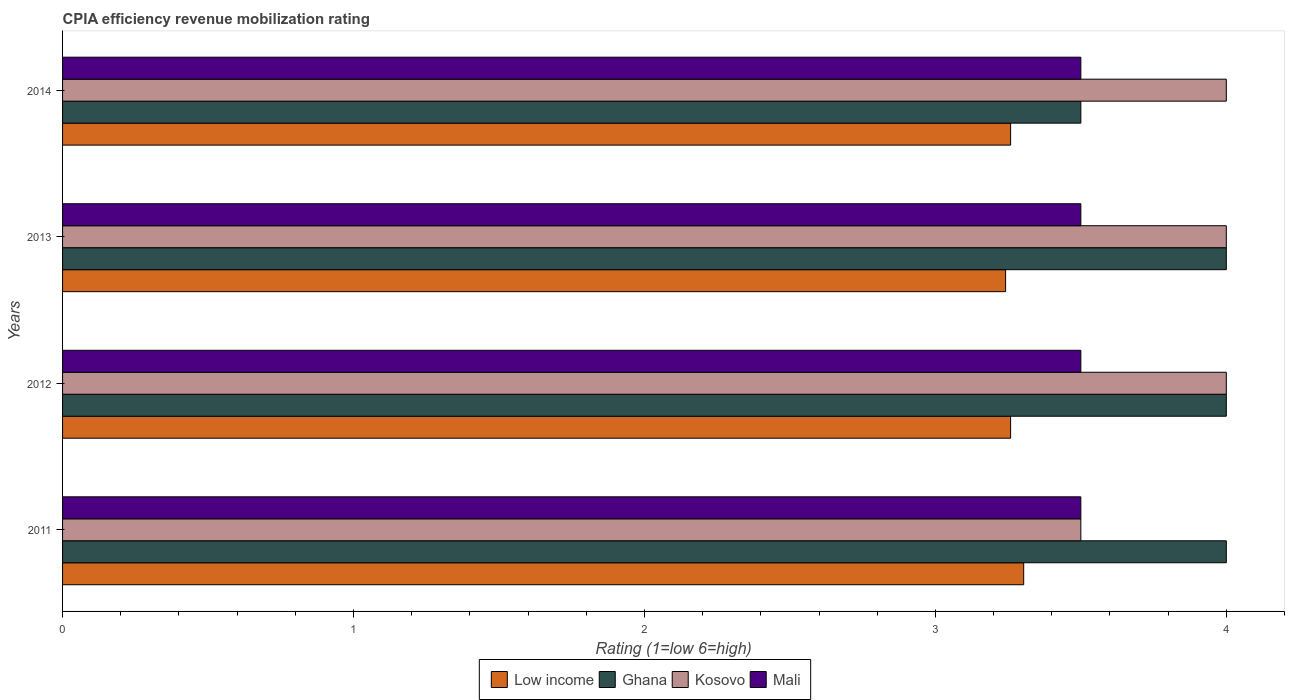How many different coloured bars are there?
Provide a short and direct response. 4. How many groups of bars are there?
Keep it short and to the point. 4. Are the number of bars on each tick of the Y-axis equal?
Provide a succinct answer. Yes. How many bars are there on the 1st tick from the top?
Give a very brief answer. 4. What is the label of the 4th group of bars from the top?
Ensure brevity in your answer.  2011. In how many cases, is the number of bars for a given year not equal to the number of legend labels?
Give a very brief answer. 0. In which year was the CPIA rating in Low income maximum?
Provide a short and direct response. 2011. In which year was the CPIA rating in Low income minimum?
Your answer should be compact. 2013. What is the total CPIA rating in Mali in the graph?
Offer a very short reply. 14. What is the difference between the CPIA rating in Mali in 2011 and that in 2012?
Your answer should be compact. 0. What is the average CPIA rating in Ghana per year?
Ensure brevity in your answer.  3.88. In the year 2014, what is the difference between the CPIA rating in Ghana and CPIA rating in Mali?
Offer a very short reply. 0. In how many years, is the CPIA rating in Mali greater than 1.2 ?
Provide a succinct answer. 4. What is the ratio of the CPIA rating in Low income in 2011 to that in 2012?
Offer a very short reply. 1.01. What is the difference between the highest and the lowest CPIA rating in Low income?
Provide a short and direct response. 0.06. In how many years, is the CPIA rating in Low income greater than the average CPIA rating in Low income taken over all years?
Your response must be concise. 1. Is the sum of the CPIA rating in Mali in 2011 and 2014 greater than the maximum CPIA rating in Low income across all years?
Keep it short and to the point. Yes. What does the 3rd bar from the top in 2012 represents?
Ensure brevity in your answer.  Ghana. What does the 2nd bar from the bottom in 2013 represents?
Give a very brief answer. Ghana. Is it the case that in every year, the sum of the CPIA rating in Low income and CPIA rating in Kosovo is greater than the CPIA rating in Ghana?
Ensure brevity in your answer.  Yes. Are all the bars in the graph horizontal?
Your response must be concise. Yes. How many years are there in the graph?
Provide a short and direct response. 4. What is the difference between two consecutive major ticks on the X-axis?
Provide a succinct answer. 1. Are the values on the major ticks of X-axis written in scientific E-notation?
Offer a very short reply. No. Does the graph contain any zero values?
Your response must be concise. No. Does the graph contain grids?
Keep it short and to the point. No. Where does the legend appear in the graph?
Make the answer very short. Bottom center. How many legend labels are there?
Keep it short and to the point. 4. How are the legend labels stacked?
Provide a succinct answer. Horizontal. What is the title of the graph?
Give a very brief answer. CPIA efficiency revenue mobilization rating. What is the label or title of the X-axis?
Provide a succinct answer. Rating (1=low 6=high). What is the Rating (1=low 6=high) in Low income in 2011?
Your answer should be compact. 3.3. What is the Rating (1=low 6=high) of Ghana in 2011?
Offer a very short reply. 4. What is the Rating (1=low 6=high) in Low income in 2012?
Offer a very short reply. 3.26. What is the Rating (1=low 6=high) of Ghana in 2012?
Offer a very short reply. 4. What is the Rating (1=low 6=high) of Kosovo in 2012?
Offer a very short reply. 4. What is the Rating (1=low 6=high) of Low income in 2013?
Offer a very short reply. 3.24. What is the Rating (1=low 6=high) of Kosovo in 2013?
Offer a very short reply. 4. What is the Rating (1=low 6=high) in Mali in 2013?
Keep it short and to the point. 3.5. What is the Rating (1=low 6=high) of Low income in 2014?
Provide a succinct answer. 3.26. What is the Rating (1=low 6=high) in Ghana in 2014?
Provide a short and direct response. 3.5. What is the Rating (1=low 6=high) of Mali in 2014?
Make the answer very short. 3.5. Across all years, what is the maximum Rating (1=low 6=high) in Low income?
Your answer should be very brief. 3.3. Across all years, what is the minimum Rating (1=low 6=high) in Low income?
Provide a short and direct response. 3.24. Across all years, what is the minimum Rating (1=low 6=high) in Kosovo?
Make the answer very short. 3.5. Across all years, what is the minimum Rating (1=low 6=high) of Mali?
Your answer should be compact. 3.5. What is the total Rating (1=low 6=high) in Low income in the graph?
Keep it short and to the point. 13.06. What is the total Rating (1=low 6=high) in Ghana in the graph?
Give a very brief answer. 15.5. What is the difference between the Rating (1=low 6=high) of Low income in 2011 and that in 2012?
Provide a short and direct response. 0.04. What is the difference between the Rating (1=low 6=high) of Ghana in 2011 and that in 2012?
Keep it short and to the point. 0. What is the difference between the Rating (1=low 6=high) of Mali in 2011 and that in 2012?
Give a very brief answer. 0. What is the difference between the Rating (1=low 6=high) in Low income in 2011 and that in 2013?
Provide a short and direct response. 0.06. What is the difference between the Rating (1=low 6=high) in Ghana in 2011 and that in 2013?
Provide a short and direct response. 0. What is the difference between the Rating (1=low 6=high) of Kosovo in 2011 and that in 2013?
Offer a very short reply. -0.5. What is the difference between the Rating (1=low 6=high) in Mali in 2011 and that in 2013?
Offer a terse response. 0. What is the difference between the Rating (1=low 6=high) of Low income in 2011 and that in 2014?
Offer a very short reply. 0.04. What is the difference between the Rating (1=low 6=high) of Kosovo in 2011 and that in 2014?
Offer a terse response. -0.5. What is the difference between the Rating (1=low 6=high) of Low income in 2012 and that in 2013?
Give a very brief answer. 0.02. What is the difference between the Rating (1=low 6=high) in Kosovo in 2012 and that in 2013?
Your answer should be compact. 0. What is the difference between the Rating (1=low 6=high) of Mali in 2012 and that in 2014?
Keep it short and to the point. 0. What is the difference between the Rating (1=low 6=high) of Low income in 2013 and that in 2014?
Give a very brief answer. -0.02. What is the difference between the Rating (1=low 6=high) of Ghana in 2013 and that in 2014?
Give a very brief answer. 0.5. What is the difference between the Rating (1=low 6=high) of Kosovo in 2013 and that in 2014?
Offer a terse response. 0. What is the difference between the Rating (1=low 6=high) of Low income in 2011 and the Rating (1=low 6=high) of Ghana in 2012?
Make the answer very short. -0.7. What is the difference between the Rating (1=low 6=high) of Low income in 2011 and the Rating (1=low 6=high) of Kosovo in 2012?
Give a very brief answer. -0.7. What is the difference between the Rating (1=low 6=high) of Low income in 2011 and the Rating (1=low 6=high) of Mali in 2012?
Ensure brevity in your answer.  -0.2. What is the difference between the Rating (1=low 6=high) of Ghana in 2011 and the Rating (1=low 6=high) of Mali in 2012?
Provide a short and direct response. 0.5. What is the difference between the Rating (1=low 6=high) of Low income in 2011 and the Rating (1=low 6=high) of Ghana in 2013?
Ensure brevity in your answer.  -0.7. What is the difference between the Rating (1=low 6=high) of Low income in 2011 and the Rating (1=low 6=high) of Kosovo in 2013?
Your response must be concise. -0.7. What is the difference between the Rating (1=low 6=high) of Low income in 2011 and the Rating (1=low 6=high) of Mali in 2013?
Provide a succinct answer. -0.2. What is the difference between the Rating (1=low 6=high) of Ghana in 2011 and the Rating (1=low 6=high) of Kosovo in 2013?
Offer a very short reply. 0. What is the difference between the Rating (1=low 6=high) in Low income in 2011 and the Rating (1=low 6=high) in Ghana in 2014?
Your answer should be very brief. -0.2. What is the difference between the Rating (1=low 6=high) in Low income in 2011 and the Rating (1=low 6=high) in Kosovo in 2014?
Offer a very short reply. -0.7. What is the difference between the Rating (1=low 6=high) of Low income in 2011 and the Rating (1=low 6=high) of Mali in 2014?
Make the answer very short. -0.2. What is the difference between the Rating (1=low 6=high) of Ghana in 2011 and the Rating (1=low 6=high) of Kosovo in 2014?
Offer a very short reply. 0. What is the difference between the Rating (1=low 6=high) of Ghana in 2011 and the Rating (1=low 6=high) of Mali in 2014?
Ensure brevity in your answer.  0.5. What is the difference between the Rating (1=low 6=high) of Low income in 2012 and the Rating (1=low 6=high) of Ghana in 2013?
Your response must be concise. -0.74. What is the difference between the Rating (1=low 6=high) in Low income in 2012 and the Rating (1=low 6=high) in Kosovo in 2013?
Ensure brevity in your answer.  -0.74. What is the difference between the Rating (1=low 6=high) in Low income in 2012 and the Rating (1=low 6=high) in Mali in 2013?
Offer a very short reply. -0.24. What is the difference between the Rating (1=low 6=high) of Low income in 2012 and the Rating (1=low 6=high) of Ghana in 2014?
Offer a very short reply. -0.24. What is the difference between the Rating (1=low 6=high) of Low income in 2012 and the Rating (1=low 6=high) of Kosovo in 2014?
Your answer should be very brief. -0.74. What is the difference between the Rating (1=low 6=high) of Low income in 2012 and the Rating (1=low 6=high) of Mali in 2014?
Your answer should be very brief. -0.24. What is the difference between the Rating (1=low 6=high) in Ghana in 2012 and the Rating (1=low 6=high) in Mali in 2014?
Your answer should be compact. 0.5. What is the difference between the Rating (1=low 6=high) of Kosovo in 2012 and the Rating (1=low 6=high) of Mali in 2014?
Make the answer very short. 0.5. What is the difference between the Rating (1=low 6=high) in Low income in 2013 and the Rating (1=low 6=high) in Ghana in 2014?
Your response must be concise. -0.26. What is the difference between the Rating (1=low 6=high) in Low income in 2013 and the Rating (1=low 6=high) in Kosovo in 2014?
Make the answer very short. -0.76. What is the difference between the Rating (1=low 6=high) in Low income in 2013 and the Rating (1=low 6=high) in Mali in 2014?
Make the answer very short. -0.26. What is the difference between the Rating (1=low 6=high) of Ghana in 2013 and the Rating (1=low 6=high) of Mali in 2014?
Give a very brief answer. 0.5. What is the difference between the Rating (1=low 6=high) of Kosovo in 2013 and the Rating (1=low 6=high) of Mali in 2014?
Offer a terse response. 0.5. What is the average Rating (1=low 6=high) of Low income per year?
Ensure brevity in your answer.  3.27. What is the average Rating (1=low 6=high) of Ghana per year?
Your answer should be very brief. 3.88. What is the average Rating (1=low 6=high) in Kosovo per year?
Ensure brevity in your answer.  3.88. What is the average Rating (1=low 6=high) of Mali per year?
Offer a terse response. 3.5. In the year 2011, what is the difference between the Rating (1=low 6=high) of Low income and Rating (1=low 6=high) of Ghana?
Offer a terse response. -0.7. In the year 2011, what is the difference between the Rating (1=low 6=high) in Low income and Rating (1=low 6=high) in Kosovo?
Keep it short and to the point. -0.2. In the year 2011, what is the difference between the Rating (1=low 6=high) in Low income and Rating (1=low 6=high) in Mali?
Provide a short and direct response. -0.2. In the year 2011, what is the difference between the Rating (1=low 6=high) of Ghana and Rating (1=low 6=high) of Kosovo?
Your response must be concise. 0.5. In the year 2011, what is the difference between the Rating (1=low 6=high) of Ghana and Rating (1=low 6=high) of Mali?
Your answer should be very brief. 0.5. In the year 2011, what is the difference between the Rating (1=low 6=high) in Kosovo and Rating (1=low 6=high) in Mali?
Offer a terse response. 0. In the year 2012, what is the difference between the Rating (1=low 6=high) of Low income and Rating (1=low 6=high) of Ghana?
Ensure brevity in your answer.  -0.74. In the year 2012, what is the difference between the Rating (1=low 6=high) of Low income and Rating (1=low 6=high) of Kosovo?
Your answer should be compact. -0.74. In the year 2012, what is the difference between the Rating (1=low 6=high) of Low income and Rating (1=low 6=high) of Mali?
Your answer should be very brief. -0.24. In the year 2012, what is the difference between the Rating (1=low 6=high) in Kosovo and Rating (1=low 6=high) in Mali?
Your answer should be compact. 0.5. In the year 2013, what is the difference between the Rating (1=low 6=high) in Low income and Rating (1=low 6=high) in Ghana?
Offer a very short reply. -0.76. In the year 2013, what is the difference between the Rating (1=low 6=high) of Low income and Rating (1=low 6=high) of Kosovo?
Your answer should be very brief. -0.76. In the year 2013, what is the difference between the Rating (1=low 6=high) in Low income and Rating (1=low 6=high) in Mali?
Provide a short and direct response. -0.26. In the year 2013, what is the difference between the Rating (1=low 6=high) in Ghana and Rating (1=low 6=high) in Kosovo?
Your answer should be compact. 0. In the year 2013, what is the difference between the Rating (1=low 6=high) in Ghana and Rating (1=low 6=high) in Mali?
Keep it short and to the point. 0.5. In the year 2014, what is the difference between the Rating (1=low 6=high) of Low income and Rating (1=low 6=high) of Ghana?
Offer a very short reply. -0.24. In the year 2014, what is the difference between the Rating (1=low 6=high) in Low income and Rating (1=low 6=high) in Kosovo?
Provide a short and direct response. -0.74. In the year 2014, what is the difference between the Rating (1=low 6=high) in Low income and Rating (1=low 6=high) in Mali?
Provide a succinct answer. -0.24. In the year 2014, what is the difference between the Rating (1=low 6=high) in Kosovo and Rating (1=low 6=high) in Mali?
Your answer should be compact. 0.5. What is the ratio of the Rating (1=low 6=high) in Low income in 2011 to that in 2012?
Ensure brevity in your answer.  1.01. What is the ratio of the Rating (1=low 6=high) of Kosovo in 2011 to that in 2012?
Provide a succinct answer. 0.88. What is the ratio of the Rating (1=low 6=high) of Mali in 2011 to that in 2012?
Give a very brief answer. 1. What is the ratio of the Rating (1=low 6=high) of Low income in 2011 to that in 2013?
Provide a short and direct response. 1.02. What is the ratio of the Rating (1=low 6=high) of Kosovo in 2011 to that in 2013?
Ensure brevity in your answer.  0.88. What is the ratio of the Rating (1=low 6=high) in Mali in 2011 to that in 2013?
Keep it short and to the point. 1. What is the ratio of the Rating (1=low 6=high) in Low income in 2011 to that in 2014?
Provide a succinct answer. 1.01. What is the ratio of the Rating (1=low 6=high) of Ghana in 2011 to that in 2014?
Offer a terse response. 1.14. What is the ratio of the Rating (1=low 6=high) of Kosovo in 2011 to that in 2014?
Your answer should be compact. 0.88. What is the ratio of the Rating (1=low 6=high) of Mali in 2012 to that in 2013?
Provide a succinct answer. 1. What is the ratio of the Rating (1=low 6=high) of Low income in 2012 to that in 2014?
Provide a succinct answer. 1. What is the ratio of the Rating (1=low 6=high) of Kosovo in 2012 to that in 2014?
Offer a terse response. 1. What is the ratio of the Rating (1=low 6=high) of Low income in 2013 to that in 2014?
Offer a very short reply. 0.99. What is the ratio of the Rating (1=low 6=high) of Mali in 2013 to that in 2014?
Offer a very short reply. 1. What is the difference between the highest and the second highest Rating (1=low 6=high) in Low income?
Your answer should be compact. 0.04. What is the difference between the highest and the second highest Rating (1=low 6=high) in Kosovo?
Provide a succinct answer. 0. What is the difference between the highest and the second highest Rating (1=low 6=high) of Mali?
Offer a terse response. 0. What is the difference between the highest and the lowest Rating (1=low 6=high) in Low income?
Provide a short and direct response. 0.06. What is the difference between the highest and the lowest Rating (1=low 6=high) in Ghana?
Your answer should be compact. 0.5. What is the difference between the highest and the lowest Rating (1=low 6=high) of Kosovo?
Provide a succinct answer. 0.5. 